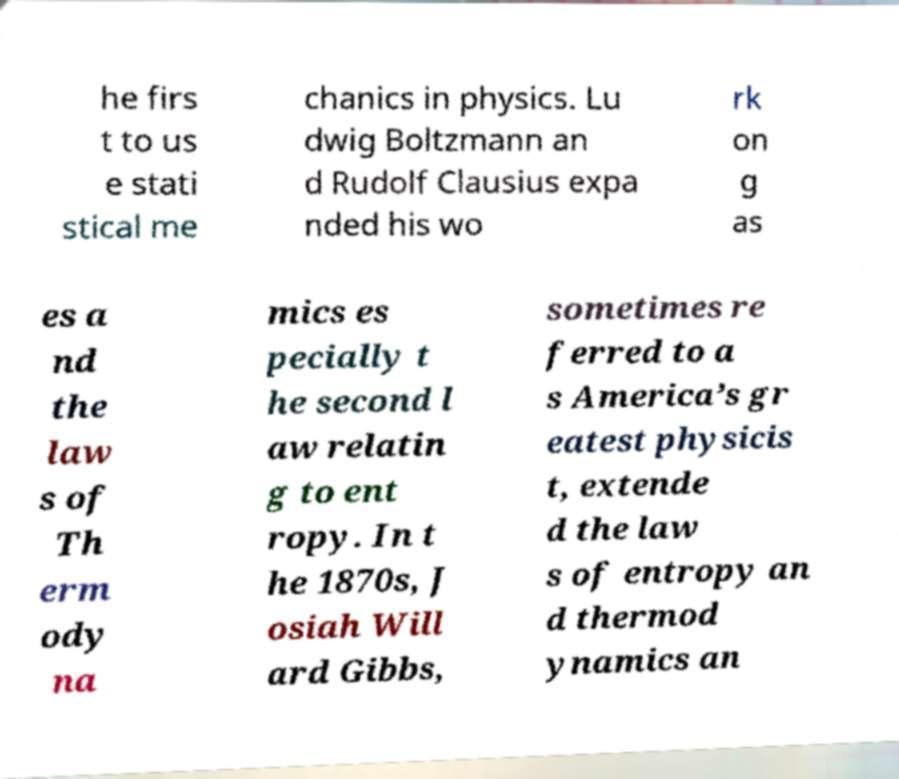Please read and relay the text visible in this image. What does it say? he firs t to us e stati stical me chanics in physics. Lu dwig Boltzmann an d Rudolf Clausius expa nded his wo rk on g as es a nd the law s of Th erm ody na mics es pecially t he second l aw relatin g to ent ropy. In t he 1870s, J osiah Will ard Gibbs, sometimes re ferred to a s America’s gr eatest physicis t, extende d the law s of entropy an d thermod ynamics an 